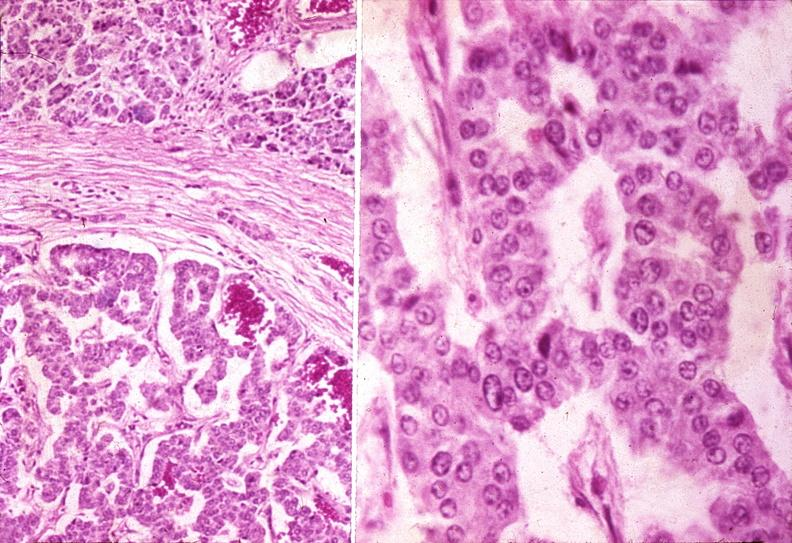where is this?
Answer the question using a single word or phrase. Pancreas 